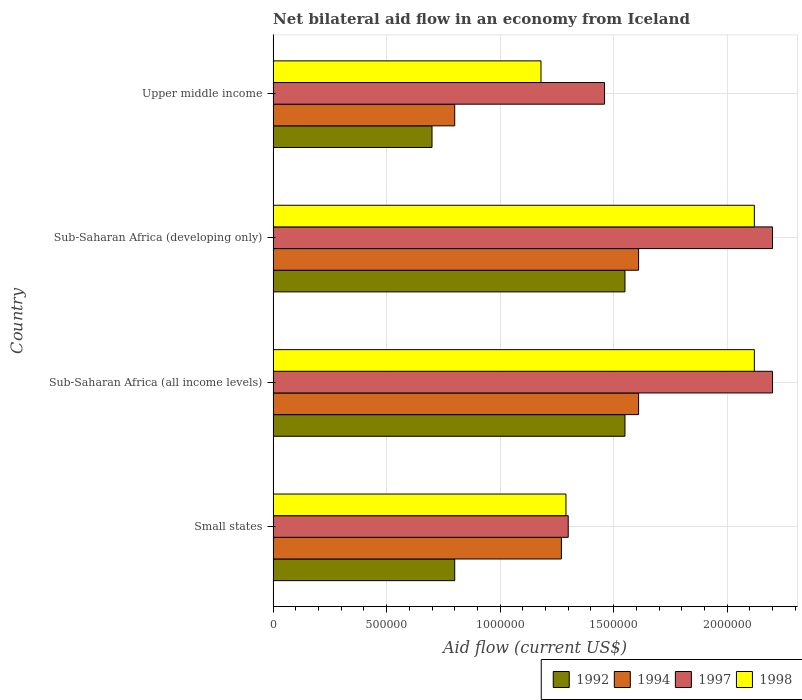Are the number of bars per tick equal to the number of legend labels?
Give a very brief answer. Yes. Are the number of bars on each tick of the Y-axis equal?
Provide a succinct answer. Yes. How many bars are there on the 1st tick from the bottom?
Offer a terse response. 4. What is the label of the 2nd group of bars from the top?
Ensure brevity in your answer.  Sub-Saharan Africa (developing only). In how many cases, is the number of bars for a given country not equal to the number of legend labels?
Keep it short and to the point. 0. What is the net bilateral aid flow in 1997 in Small states?
Provide a succinct answer. 1.30e+06. Across all countries, what is the maximum net bilateral aid flow in 1998?
Offer a terse response. 2.12e+06. In which country was the net bilateral aid flow in 1994 maximum?
Ensure brevity in your answer.  Sub-Saharan Africa (all income levels). In which country was the net bilateral aid flow in 1998 minimum?
Your answer should be compact. Upper middle income. What is the total net bilateral aid flow in 1997 in the graph?
Keep it short and to the point. 7.16e+06. What is the difference between the net bilateral aid flow in 1992 in Small states and that in Sub-Saharan Africa (all income levels)?
Keep it short and to the point. -7.50e+05. What is the average net bilateral aid flow in 1992 per country?
Your response must be concise. 1.15e+06. What is the difference between the net bilateral aid flow in 1994 and net bilateral aid flow in 1998 in Sub-Saharan Africa (all income levels)?
Provide a short and direct response. -5.10e+05. In how many countries, is the net bilateral aid flow in 1997 greater than 500000 US$?
Keep it short and to the point. 4. What is the ratio of the net bilateral aid flow in 1994 in Sub-Saharan Africa (developing only) to that in Upper middle income?
Provide a succinct answer. 2.01. Is the net bilateral aid flow in 1992 in Sub-Saharan Africa (all income levels) less than that in Upper middle income?
Provide a short and direct response. No. Is the difference between the net bilateral aid flow in 1994 in Small states and Sub-Saharan Africa (developing only) greater than the difference between the net bilateral aid flow in 1998 in Small states and Sub-Saharan Africa (developing only)?
Ensure brevity in your answer.  Yes. What is the difference between the highest and the second highest net bilateral aid flow in 1997?
Your response must be concise. 0. What is the difference between the highest and the lowest net bilateral aid flow in 1997?
Provide a succinct answer. 9.00e+05. In how many countries, is the net bilateral aid flow in 1992 greater than the average net bilateral aid flow in 1992 taken over all countries?
Your response must be concise. 2. Is it the case that in every country, the sum of the net bilateral aid flow in 1997 and net bilateral aid flow in 1992 is greater than the sum of net bilateral aid flow in 1994 and net bilateral aid flow in 1998?
Make the answer very short. No. How many bars are there?
Provide a succinct answer. 16. How many countries are there in the graph?
Provide a short and direct response. 4. What is the difference between two consecutive major ticks on the X-axis?
Keep it short and to the point. 5.00e+05. Does the graph contain any zero values?
Ensure brevity in your answer.  No. Where does the legend appear in the graph?
Provide a short and direct response. Bottom right. How many legend labels are there?
Provide a succinct answer. 4. What is the title of the graph?
Your response must be concise. Net bilateral aid flow in an economy from Iceland. Does "2007" appear as one of the legend labels in the graph?
Keep it short and to the point. No. What is the Aid flow (current US$) in 1994 in Small states?
Make the answer very short. 1.27e+06. What is the Aid flow (current US$) of 1997 in Small states?
Your answer should be very brief. 1.30e+06. What is the Aid flow (current US$) in 1998 in Small states?
Keep it short and to the point. 1.29e+06. What is the Aid flow (current US$) in 1992 in Sub-Saharan Africa (all income levels)?
Ensure brevity in your answer.  1.55e+06. What is the Aid flow (current US$) in 1994 in Sub-Saharan Africa (all income levels)?
Keep it short and to the point. 1.61e+06. What is the Aid flow (current US$) of 1997 in Sub-Saharan Africa (all income levels)?
Your response must be concise. 2.20e+06. What is the Aid flow (current US$) in 1998 in Sub-Saharan Africa (all income levels)?
Offer a very short reply. 2.12e+06. What is the Aid flow (current US$) of 1992 in Sub-Saharan Africa (developing only)?
Give a very brief answer. 1.55e+06. What is the Aid flow (current US$) in 1994 in Sub-Saharan Africa (developing only)?
Ensure brevity in your answer.  1.61e+06. What is the Aid flow (current US$) of 1997 in Sub-Saharan Africa (developing only)?
Keep it short and to the point. 2.20e+06. What is the Aid flow (current US$) of 1998 in Sub-Saharan Africa (developing only)?
Your response must be concise. 2.12e+06. What is the Aid flow (current US$) in 1994 in Upper middle income?
Keep it short and to the point. 8.00e+05. What is the Aid flow (current US$) of 1997 in Upper middle income?
Keep it short and to the point. 1.46e+06. What is the Aid flow (current US$) of 1998 in Upper middle income?
Make the answer very short. 1.18e+06. Across all countries, what is the maximum Aid flow (current US$) of 1992?
Provide a succinct answer. 1.55e+06. Across all countries, what is the maximum Aid flow (current US$) in 1994?
Make the answer very short. 1.61e+06. Across all countries, what is the maximum Aid flow (current US$) of 1997?
Give a very brief answer. 2.20e+06. Across all countries, what is the maximum Aid flow (current US$) in 1998?
Your answer should be compact. 2.12e+06. Across all countries, what is the minimum Aid flow (current US$) of 1997?
Your response must be concise. 1.30e+06. Across all countries, what is the minimum Aid flow (current US$) in 1998?
Give a very brief answer. 1.18e+06. What is the total Aid flow (current US$) in 1992 in the graph?
Keep it short and to the point. 4.60e+06. What is the total Aid flow (current US$) of 1994 in the graph?
Provide a short and direct response. 5.29e+06. What is the total Aid flow (current US$) in 1997 in the graph?
Ensure brevity in your answer.  7.16e+06. What is the total Aid flow (current US$) in 1998 in the graph?
Provide a succinct answer. 6.71e+06. What is the difference between the Aid flow (current US$) in 1992 in Small states and that in Sub-Saharan Africa (all income levels)?
Offer a terse response. -7.50e+05. What is the difference between the Aid flow (current US$) of 1997 in Small states and that in Sub-Saharan Africa (all income levels)?
Ensure brevity in your answer.  -9.00e+05. What is the difference between the Aid flow (current US$) of 1998 in Small states and that in Sub-Saharan Africa (all income levels)?
Provide a short and direct response. -8.30e+05. What is the difference between the Aid flow (current US$) in 1992 in Small states and that in Sub-Saharan Africa (developing only)?
Your response must be concise. -7.50e+05. What is the difference between the Aid flow (current US$) in 1994 in Small states and that in Sub-Saharan Africa (developing only)?
Provide a short and direct response. -3.40e+05. What is the difference between the Aid flow (current US$) in 1997 in Small states and that in Sub-Saharan Africa (developing only)?
Ensure brevity in your answer.  -9.00e+05. What is the difference between the Aid flow (current US$) in 1998 in Small states and that in Sub-Saharan Africa (developing only)?
Give a very brief answer. -8.30e+05. What is the difference between the Aid flow (current US$) in 1992 in Small states and that in Upper middle income?
Offer a very short reply. 1.00e+05. What is the difference between the Aid flow (current US$) of 1994 in Small states and that in Upper middle income?
Your answer should be very brief. 4.70e+05. What is the difference between the Aid flow (current US$) of 1997 in Small states and that in Upper middle income?
Your response must be concise. -1.60e+05. What is the difference between the Aid flow (current US$) in 1992 in Sub-Saharan Africa (all income levels) and that in Upper middle income?
Offer a terse response. 8.50e+05. What is the difference between the Aid flow (current US$) in 1994 in Sub-Saharan Africa (all income levels) and that in Upper middle income?
Your answer should be very brief. 8.10e+05. What is the difference between the Aid flow (current US$) in 1997 in Sub-Saharan Africa (all income levels) and that in Upper middle income?
Your answer should be very brief. 7.40e+05. What is the difference between the Aid flow (current US$) in 1998 in Sub-Saharan Africa (all income levels) and that in Upper middle income?
Ensure brevity in your answer.  9.40e+05. What is the difference between the Aid flow (current US$) in 1992 in Sub-Saharan Africa (developing only) and that in Upper middle income?
Provide a short and direct response. 8.50e+05. What is the difference between the Aid flow (current US$) in 1994 in Sub-Saharan Africa (developing only) and that in Upper middle income?
Provide a short and direct response. 8.10e+05. What is the difference between the Aid flow (current US$) in 1997 in Sub-Saharan Africa (developing only) and that in Upper middle income?
Keep it short and to the point. 7.40e+05. What is the difference between the Aid flow (current US$) of 1998 in Sub-Saharan Africa (developing only) and that in Upper middle income?
Your answer should be very brief. 9.40e+05. What is the difference between the Aid flow (current US$) in 1992 in Small states and the Aid flow (current US$) in 1994 in Sub-Saharan Africa (all income levels)?
Your answer should be compact. -8.10e+05. What is the difference between the Aid flow (current US$) in 1992 in Small states and the Aid flow (current US$) in 1997 in Sub-Saharan Africa (all income levels)?
Provide a succinct answer. -1.40e+06. What is the difference between the Aid flow (current US$) of 1992 in Small states and the Aid flow (current US$) of 1998 in Sub-Saharan Africa (all income levels)?
Offer a terse response. -1.32e+06. What is the difference between the Aid flow (current US$) of 1994 in Small states and the Aid flow (current US$) of 1997 in Sub-Saharan Africa (all income levels)?
Offer a very short reply. -9.30e+05. What is the difference between the Aid flow (current US$) of 1994 in Small states and the Aid flow (current US$) of 1998 in Sub-Saharan Africa (all income levels)?
Keep it short and to the point. -8.50e+05. What is the difference between the Aid flow (current US$) of 1997 in Small states and the Aid flow (current US$) of 1998 in Sub-Saharan Africa (all income levels)?
Your answer should be very brief. -8.20e+05. What is the difference between the Aid flow (current US$) of 1992 in Small states and the Aid flow (current US$) of 1994 in Sub-Saharan Africa (developing only)?
Give a very brief answer. -8.10e+05. What is the difference between the Aid flow (current US$) of 1992 in Small states and the Aid flow (current US$) of 1997 in Sub-Saharan Africa (developing only)?
Give a very brief answer. -1.40e+06. What is the difference between the Aid flow (current US$) in 1992 in Small states and the Aid flow (current US$) in 1998 in Sub-Saharan Africa (developing only)?
Your answer should be very brief. -1.32e+06. What is the difference between the Aid flow (current US$) of 1994 in Small states and the Aid flow (current US$) of 1997 in Sub-Saharan Africa (developing only)?
Your answer should be compact. -9.30e+05. What is the difference between the Aid flow (current US$) in 1994 in Small states and the Aid flow (current US$) in 1998 in Sub-Saharan Africa (developing only)?
Provide a succinct answer. -8.50e+05. What is the difference between the Aid flow (current US$) of 1997 in Small states and the Aid flow (current US$) of 1998 in Sub-Saharan Africa (developing only)?
Ensure brevity in your answer.  -8.20e+05. What is the difference between the Aid flow (current US$) of 1992 in Small states and the Aid flow (current US$) of 1994 in Upper middle income?
Your answer should be very brief. 0. What is the difference between the Aid flow (current US$) in 1992 in Small states and the Aid flow (current US$) in 1997 in Upper middle income?
Ensure brevity in your answer.  -6.60e+05. What is the difference between the Aid flow (current US$) in 1992 in Small states and the Aid flow (current US$) in 1998 in Upper middle income?
Make the answer very short. -3.80e+05. What is the difference between the Aid flow (current US$) in 1994 in Small states and the Aid flow (current US$) in 1998 in Upper middle income?
Keep it short and to the point. 9.00e+04. What is the difference between the Aid flow (current US$) in 1997 in Small states and the Aid flow (current US$) in 1998 in Upper middle income?
Offer a very short reply. 1.20e+05. What is the difference between the Aid flow (current US$) of 1992 in Sub-Saharan Africa (all income levels) and the Aid flow (current US$) of 1997 in Sub-Saharan Africa (developing only)?
Provide a short and direct response. -6.50e+05. What is the difference between the Aid flow (current US$) of 1992 in Sub-Saharan Africa (all income levels) and the Aid flow (current US$) of 1998 in Sub-Saharan Africa (developing only)?
Ensure brevity in your answer.  -5.70e+05. What is the difference between the Aid flow (current US$) in 1994 in Sub-Saharan Africa (all income levels) and the Aid flow (current US$) in 1997 in Sub-Saharan Africa (developing only)?
Give a very brief answer. -5.90e+05. What is the difference between the Aid flow (current US$) in 1994 in Sub-Saharan Africa (all income levels) and the Aid flow (current US$) in 1998 in Sub-Saharan Africa (developing only)?
Make the answer very short. -5.10e+05. What is the difference between the Aid flow (current US$) of 1997 in Sub-Saharan Africa (all income levels) and the Aid flow (current US$) of 1998 in Sub-Saharan Africa (developing only)?
Provide a short and direct response. 8.00e+04. What is the difference between the Aid flow (current US$) of 1992 in Sub-Saharan Africa (all income levels) and the Aid flow (current US$) of 1994 in Upper middle income?
Your answer should be very brief. 7.50e+05. What is the difference between the Aid flow (current US$) of 1992 in Sub-Saharan Africa (all income levels) and the Aid flow (current US$) of 1998 in Upper middle income?
Provide a short and direct response. 3.70e+05. What is the difference between the Aid flow (current US$) in 1994 in Sub-Saharan Africa (all income levels) and the Aid flow (current US$) in 1998 in Upper middle income?
Ensure brevity in your answer.  4.30e+05. What is the difference between the Aid flow (current US$) of 1997 in Sub-Saharan Africa (all income levels) and the Aid flow (current US$) of 1998 in Upper middle income?
Give a very brief answer. 1.02e+06. What is the difference between the Aid flow (current US$) in 1992 in Sub-Saharan Africa (developing only) and the Aid flow (current US$) in 1994 in Upper middle income?
Give a very brief answer. 7.50e+05. What is the difference between the Aid flow (current US$) of 1994 in Sub-Saharan Africa (developing only) and the Aid flow (current US$) of 1997 in Upper middle income?
Offer a very short reply. 1.50e+05. What is the difference between the Aid flow (current US$) of 1994 in Sub-Saharan Africa (developing only) and the Aid flow (current US$) of 1998 in Upper middle income?
Offer a terse response. 4.30e+05. What is the difference between the Aid flow (current US$) of 1997 in Sub-Saharan Africa (developing only) and the Aid flow (current US$) of 1998 in Upper middle income?
Your answer should be compact. 1.02e+06. What is the average Aid flow (current US$) in 1992 per country?
Ensure brevity in your answer.  1.15e+06. What is the average Aid flow (current US$) of 1994 per country?
Your answer should be very brief. 1.32e+06. What is the average Aid flow (current US$) of 1997 per country?
Give a very brief answer. 1.79e+06. What is the average Aid flow (current US$) in 1998 per country?
Offer a terse response. 1.68e+06. What is the difference between the Aid flow (current US$) of 1992 and Aid flow (current US$) of 1994 in Small states?
Provide a short and direct response. -4.70e+05. What is the difference between the Aid flow (current US$) in 1992 and Aid flow (current US$) in 1997 in Small states?
Give a very brief answer. -5.00e+05. What is the difference between the Aid flow (current US$) in 1992 and Aid flow (current US$) in 1998 in Small states?
Offer a terse response. -4.90e+05. What is the difference between the Aid flow (current US$) in 1994 and Aid flow (current US$) in 1997 in Small states?
Make the answer very short. -3.00e+04. What is the difference between the Aid flow (current US$) in 1997 and Aid flow (current US$) in 1998 in Small states?
Keep it short and to the point. 10000. What is the difference between the Aid flow (current US$) in 1992 and Aid flow (current US$) in 1994 in Sub-Saharan Africa (all income levels)?
Provide a short and direct response. -6.00e+04. What is the difference between the Aid flow (current US$) of 1992 and Aid flow (current US$) of 1997 in Sub-Saharan Africa (all income levels)?
Ensure brevity in your answer.  -6.50e+05. What is the difference between the Aid flow (current US$) in 1992 and Aid flow (current US$) in 1998 in Sub-Saharan Africa (all income levels)?
Keep it short and to the point. -5.70e+05. What is the difference between the Aid flow (current US$) in 1994 and Aid flow (current US$) in 1997 in Sub-Saharan Africa (all income levels)?
Make the answer very short. -5.90e+05. What is the difference between the Aid flow (current US$) of 1994 and Aid flow (current US$) of 1998 in Sub-Saharan Africa (all income levels)?
Your answer should be compact. -5.10e+05. What is the difference between the Aid flow (current US$) in 1992 and Aid flow (current US$) in 1997 in Sub-Saharan Africa (developing only)?
Your response must be concise. -6.50e+05. What is the difference between the Aid flow (current US$) in 1992 and Aid flow (current US$) in 1998 in Sub-Saharan Africa (developing only)?
Offer a very short reply. -5.70e+05. What is the difference between the Aid flow (current US$) of 1994 and Aid flow (current US$) of 1997 in Sub-Saharan Africa (developing only)?
Ensure brevity in your answer.  -5.90e+05. What is the difference between the Aid flow (current US$) in 1994 and Aid flow (current US$) in 1998 in Sub-Saharan Africa (developing only)?
Give a very brief answer. -5.10e+05. What is the difference between the Aid flow (current US$) in 1992 and Aid flow (current US$) in 1994 in Upper middle income?
Give a very brief answer. -1.00e+05. What is the difference between the Aid flow (current US$) in 1992 and Aid flow (current US$) in 1997 in Upper middle income?
Offer a terse response. -7.60e+05. What is the difference between the Aid flow (current US$) in 1992 and Aid flow (current US$) in 1998 in Upper middle income?
Offer a very short reply. -4.80e+05. What is the difference between the Aid flow (current US$) in 1994 and Aid flow (current US$) in 1997 in Upper middle income?
Ensure brevity in your answer.  -6.60e+05. What is the difference between the Aid flow (current US$) in 1994 and Aid flow (current US$) in 1998 in Upper middle income?
Your answer should be very brief. -3.80e+05. What is the difference between the Aid flow (current US$) of 1997 and Aid flow (current US$) of 1998 in Upper middle income?
Give a very brief answer. 2.80e+05. What is the ratio of the Aid flow (current US$) of 1992 in Small states to that in Sub-Saharan Africa (all income levels)?
Provide a short and direct response. 0.52. What is the ratio of the Aid flow (current US$) in 1994 in Small states to that in Sub-Saharan Africa (all income levels)?
Offer a very short reply. 0.79. What is the ratio of the Aid flow (current US$) of 1997 in Small states to that in Sub-Saharan Africa (all income levels)?
Give a very brief answer. 0.59. What is the ratio of the Aid flow (current US$) of 1998 in Small states to that in Sub-Saharan Africa (all income levels)?
Provide a short and direct response. 0.61. What is the ratio of the Aid flow (current US$) of 1992 in Small states to that in Sub-Saharan Africa (developing only)?
Offer a terse response. 0.52. What is the ratio of the Aid flow (current US$) in 1994 in Small states to that in Sub-Saharan Africa (developing only)?
Your answer should be very brief. 0.79. What is the ratio of the Aid flow (current US$) of 1997 in Small states to that in Sub-Saharan Africa (developing only)?
Ensure brevity in your answer.  0.59. What is the ratio of the Aid flow (current US$) of 1998 in Small states to that in Sub-Saharan Africa (developing only)?
Give a very brief answer. 0.61. What is the ratio of the Aid flow (current US$) in 1992 in Small states to that in Upper middle income?
Offer a terse response. 1.14. What is the ratio of the Aid flow (current US$) in 1994 in Small states to that in Upper middle income?
Provide a succinct answer. 1.59. What is the ratio of the Aid flow (current US$) of 1997 in Small states to that in Upper middle income?
Give a very brief answer. 0.89. What is the ratio of the Aid flow (current US$) in 1998 in Small states to that in Upper middle income?
Provide a short and direct response. 1.09. What is the ratio of the Aid flow (current US$) of 1992 in Sub-Saharan Africa (all income levels) to that in Sub-Saharan Africa (developing only)?
Your answer should be compact. 1. What is the ratio of the Aid flow (current US$) in 1994 in Sub-Saharan Africa (all income levels) to that in Sub-Saharan Africa (developing only)?
Keep it short and to the point. 1. What is the ratio of the Aid flow (current US$) in 1997 in Sub-Saharan Africa (all income levels) to that in Sub-Saharan Africa (developing only)?
Ensure brevity in your answer.  1. What is the ratio of the Aid flow (current US$) of 1998 in Sub-Saharan Africa (all income levels) to that in Sub-Saharan Africa (developing only)?
Give a very brief answer. 1. What is the ratio of the Aid flow (current US$) in 1992 in Sub-Saharan Africa (all income levels) to that in Upper middle income?
Your answer should be compact. 2.21. What is the ratio of the Aid flow (current US$) in 1994 in Sub-Saharan Africa (all income levels) to that in Upper middle income?
Offer a very short reply. 2.01. What is the ratio of the Aid flow (current US$) in 1997 in Sub-Saharan Africa (all income levels) to that in Upper middle income?
Offer a very short reply. 1.51. What is the ratio of the Aid flow (current US$) of 1998 in Sub-Saharan Africa (all income levels) to that in Upper middle income?
Your answer should be very brief. 1.8. What is the ratio of the Aid flow (current US$) in 1992 in Sub-Saharan Africa (developing only) to that in Upper middle income?
Offer a terse response. 2.21. What is the ratio of the Aid flow (current US$) of 1994 in Sub-Saharan Africa (developing only) to that in Upper middle income?
Provide a short and direct response. 2.01. What is the ratio of the Aid flow (current US$) of 1997 in Sub-Saharan Africa (developing only) to that in Upper middle income?
Keep it short and to the point. 1.51. What is the ratio of the Aid flow (current US$) of 1998 in Sub-Saharan Africa (developing only) to that in Upper middle income?
Make the answer very short. 1.8. What is the difference between the highest and the second highest Aid flow (current US$) in 1997?
Keep it short and to the point. 0. What is the difference between the highest and the lowest Aid flow (current US$) of 1992?
Keep it short and to the point. 8.50e+05. What is the difference between the highest and the lowest Aid flow (current US$) of 1994?
Provide a succinct answer. 8.10e+05. What is the difference between the highest and the lowest Aid flow (current US$) of 1997?
Ensure brevity in your answer.  9.00e+05. What is the difference between the highest and the lowest Aid flow (current US$) in 1998?
Offer a very short reply. 9.40e+05. 